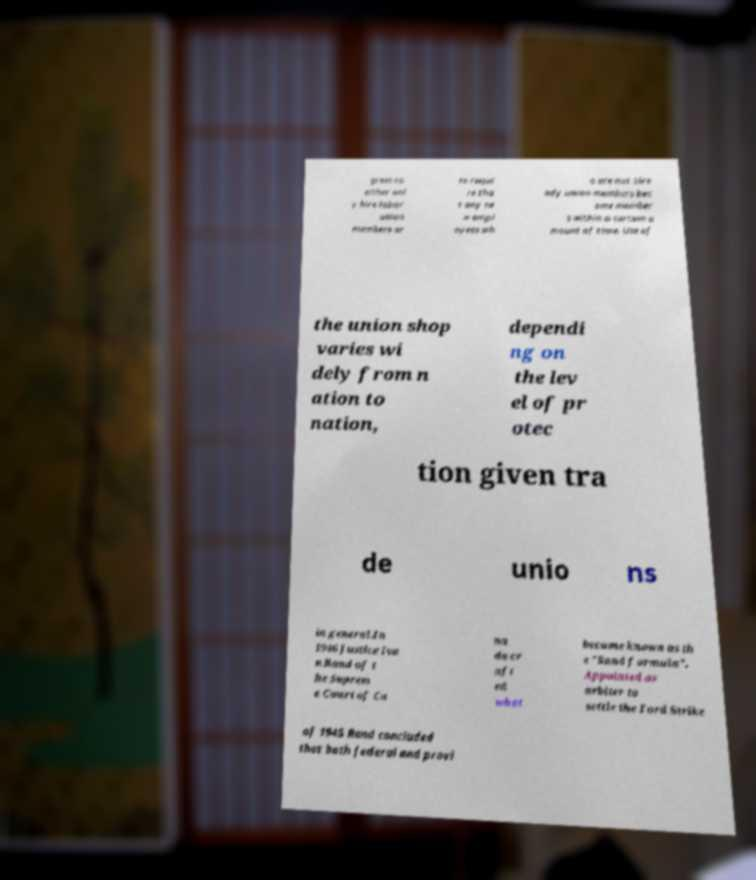Could you extract and type out the text from this image? grees to either onl y hire labor union members or to requi re tha t any ne w empl oyees wh o are not alre ady union members bec ome member s within a certain a mount of time. Use of the union shop varies wi dely from n ation to nation, dependi ng on the lev el of pr otec tion given tra de unio ns in general.In 1946 Justice Iva n Rand of t he Suprem e Court of Ca na da cr aft ed what became known as th e "Rand formula". Appointed as arbiter to settle the Ford Strike of 1945 Rand concluded that both federal and provi 